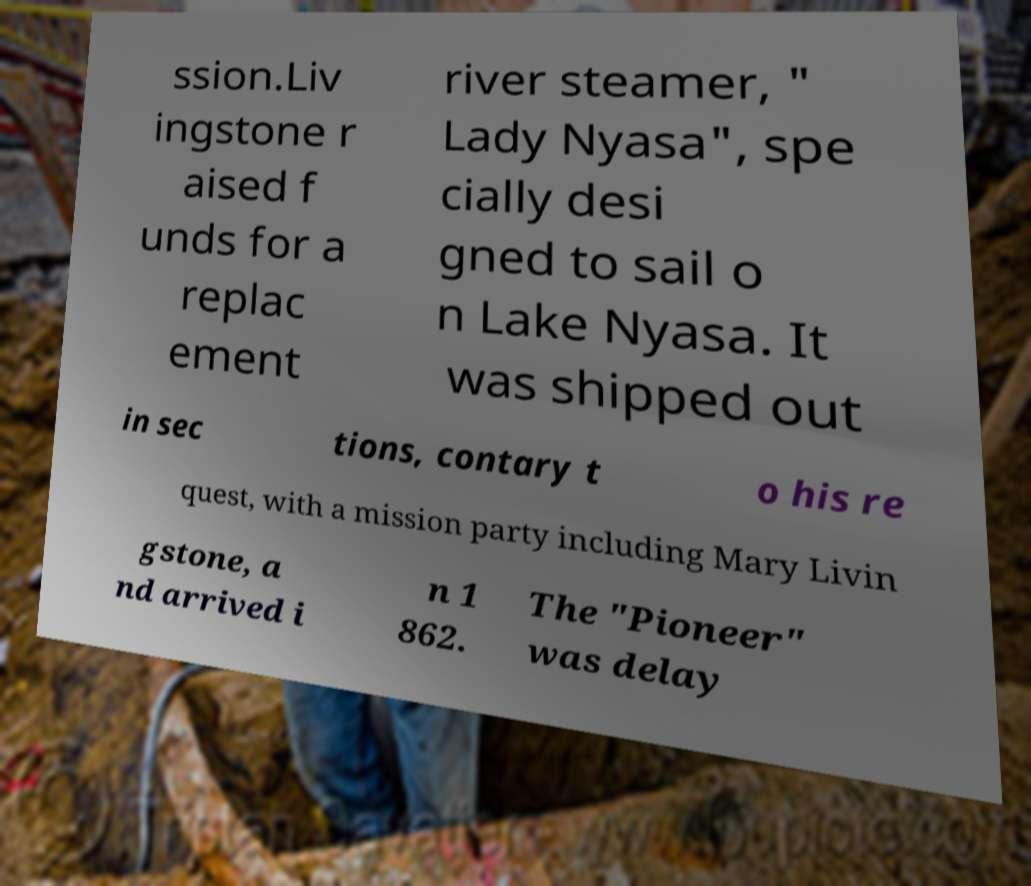Please identify and transcribe the text found in this image. ssion.Liv ingstone r aised f unds for a replac ement river steamer, " Lady Nyasa", spe cially desi gned to sail o n Lake Nyasa. It was shipped out in sec tions, contary t o his re quest, with a mission party including Mary Livin gstone, a nd arrived i n 1 862. The "Pioneer" was delay 